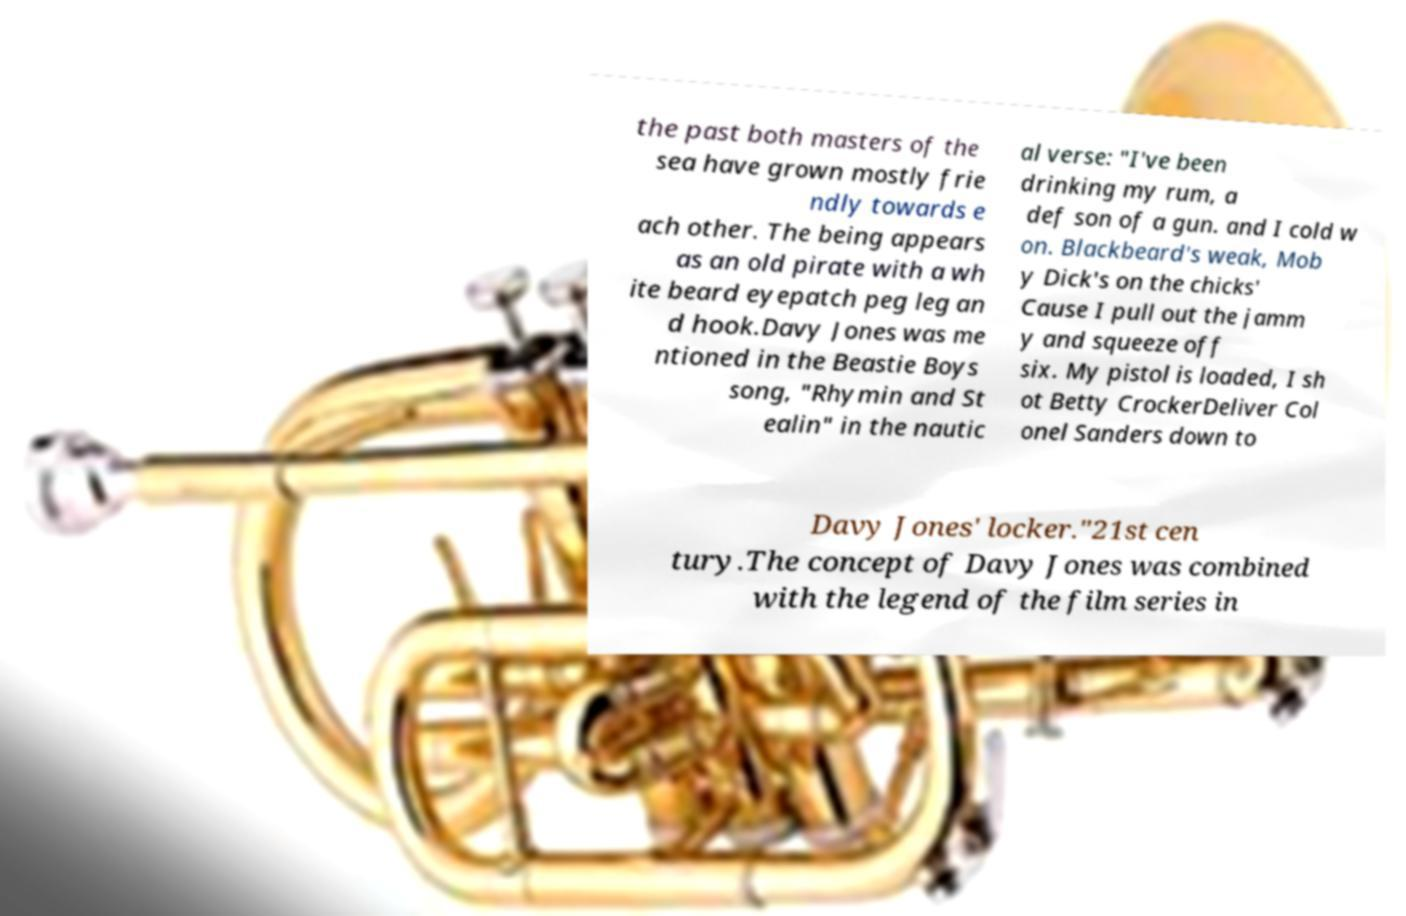Can you read and provide the text displayed in the image?This photo seems to have some interesting text. Can you extract and type it out for me? the past both masters of the sea have grown mostly frie ndly towards e ach other. The being appears as an old pirate with a wh ite beard eyepatch peg leg an d hook.Davy Jones was me ntioned in the Beastie Boys song, "Rhymin and St ealin" in the nautic al verse: "I've been drinking my rum, a def son of a gun. and I cold w on. Blackbeard's weak, Mob y Dick's on the chicks' Cause I pull out the jamm y and squeeze off six. My pistol is loaded, I sh ot Betty CrockerDeliver Col onel Sanders down to Davy Jones' locker."21st cen tury.The concept of Davy Jones was combined with the legend of the film series in 